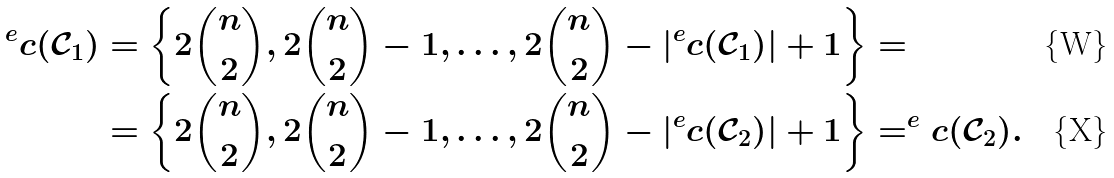Convert formula to latex. <formula><loc_0><loc_0><loc_500><loc_500>^ { e } c ( \mathcal { C } _ { 1 } ) & = \left \{ 2 \binom { n } { 2 } , 2 \binom { n } { 2 } - 1 , \dots , 2 \binom { n } { 2 } - | ^ { e } c ( \mathcal { C } _ { 1 } ) | + 1 \right \} = \\ & = \left \{ 2 \binom { n } { 2 } , 2 \binom { n } { 2 } - 1 , \dots , 2 \binom { n } { 2 } - | ^ { e } c ( \mathcal { C } _ { 2 } ) | + 1 \right \} = ^ { e } c ( \mathcal { C } _ { 2 } ) .</formula> 